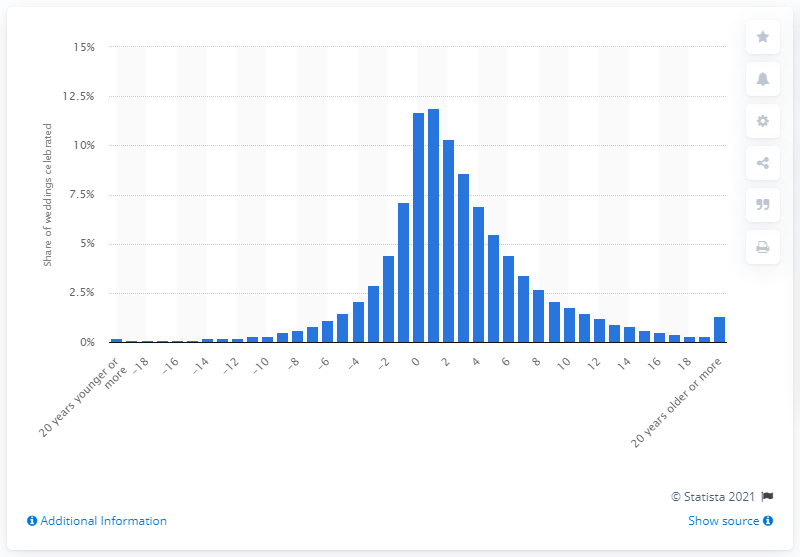Mention a couple of crucial points in this snapshot. According to data from 2017, approximately 12% of opposite-sex couples in France got married. 